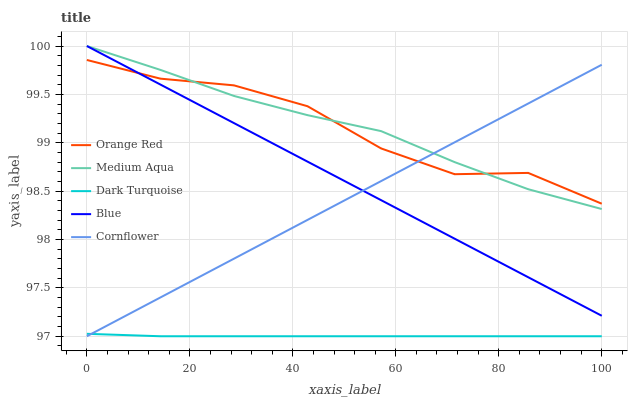Does Dark Turquoise have the minimum area under the curve?
Answer yes or no. Yes. Does Medium Aqua have the maximum area under the curve?
Answer yes or no. Yes. Does Medium Aqua have the minimum area under the curve?
Answer yes or no. No. Does Dark Turquoise have the maximum area under the curve?
Answer yes or no. No. Is Blue the smoothest?
Answer yes or no. Yes. Is Orange Red the roughest?
Answer yes or no. Yes. Is Dark Turquoise the smoothest?
Answer yes or no. No. Is Dark Turquoise the roughest?
Answer yes or no. No. Does Medium Aqua have the lowest value?
Answer yes or no. No. Does Medium Aqua have the highest value?
Answer yes or no. Yes. Does Dark Turquoise have the highest value?
Answer yes or no. No. Is Dark Turquoise less than Orange Red?
Answer yes or no. Yes. Is Medium Aqua greater than Dark Turquoise?
Answer yes or no. Yes. Does Cornflower intersect Blue?
Answer yes or no. Yes. Is Cornflower less than Blue?
Answer yes or no. No. Is Cornflower greater than Blue?
Answer yes or no. No. Does Dark Turquoise intersect Orange Red?
Answer yes or no. No. 